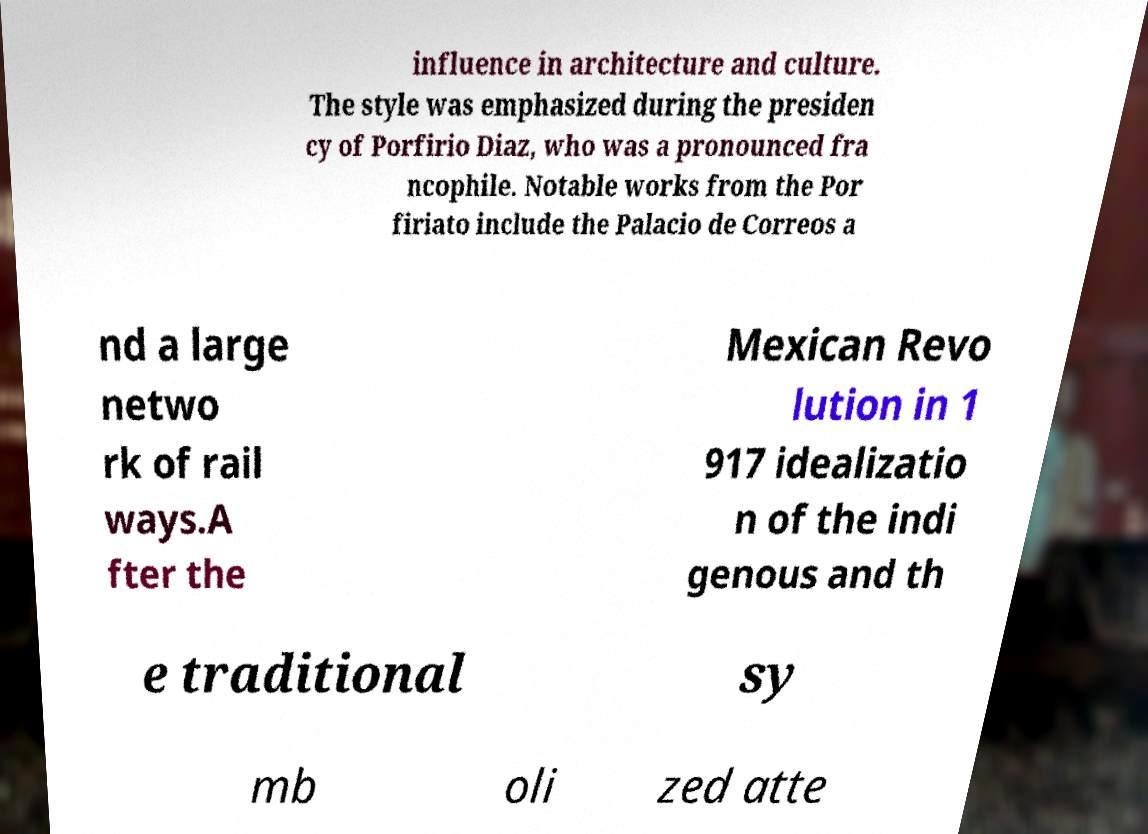Can you accurately transcribe the text from the provided image for me? influence in architecture and culture. The style was emphasized during the presiden cy of Porfirio Diaz, who was a pronounced fra ncophile. Notable works from the Por firiato include the Palacio de Correos a nd a large netwo rk of rail ways.A fter the Mexican Revo lution in 1 917 idealizatio n of the indi genous and th e traditional sy mb oli zed atte 